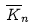<formula> <loc_0><loc_0><loc_500><loc_500>\overline { K } _ { n }</formula> 